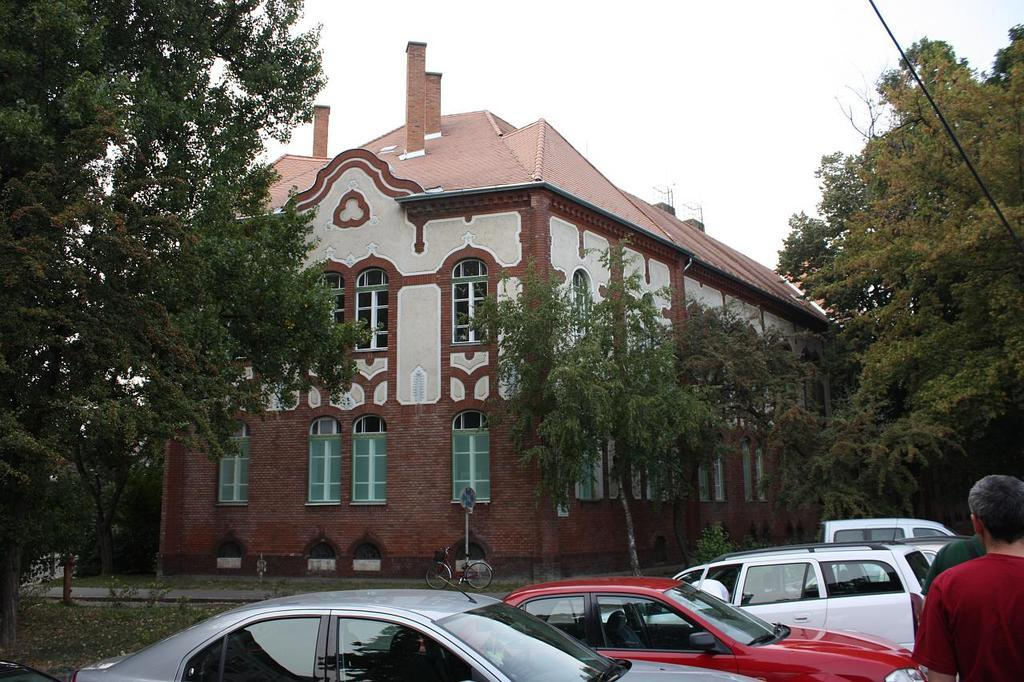What can be seen in the image? There are vehicles in the image. Where are the people located in the image? The people are to the right of the image. What is visible in the background of the image? There are trees, a building with windows, and the sky visible in the background of the image. What type of bird is sitting on the wall in the image? There is no bird or wall present in the image. 